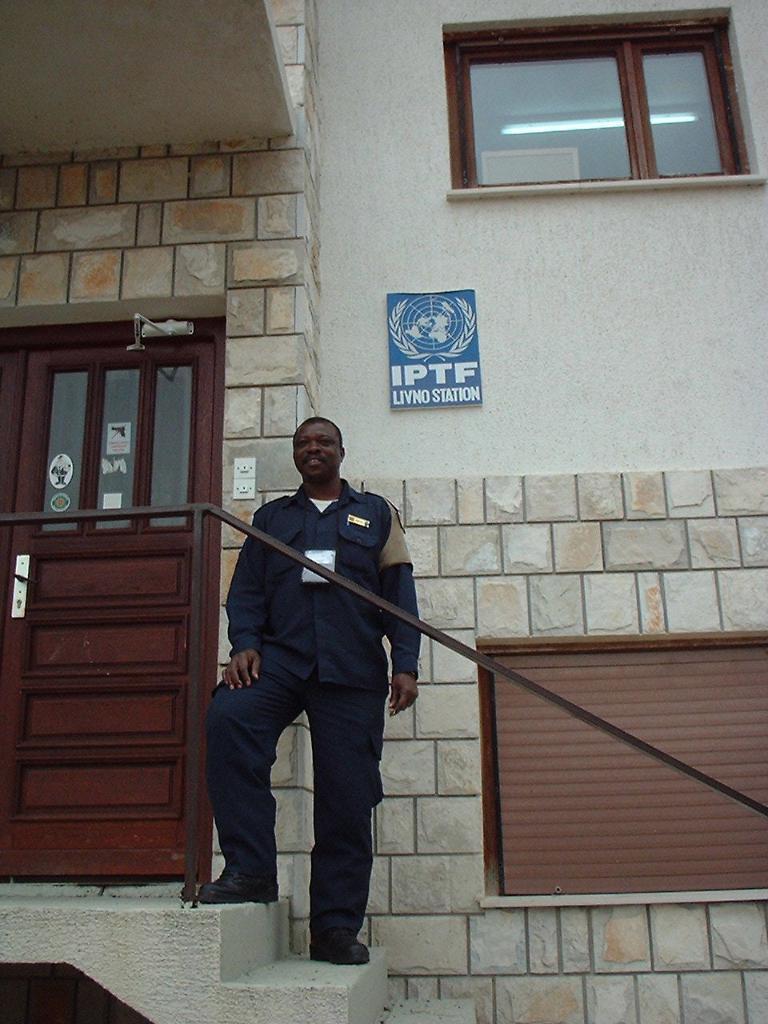Could you give a brief overview of what you see in this image? The man in the middle of the picture wearing blue shirt and blue pant is standing on the staircase. Behind him, we see a wall which is made up of cobblestones and beside that, we see a white wall on which blue board with some text written in white color is placed. Beside him, we see a door in brown color and at the top of the picture, we see a window. 